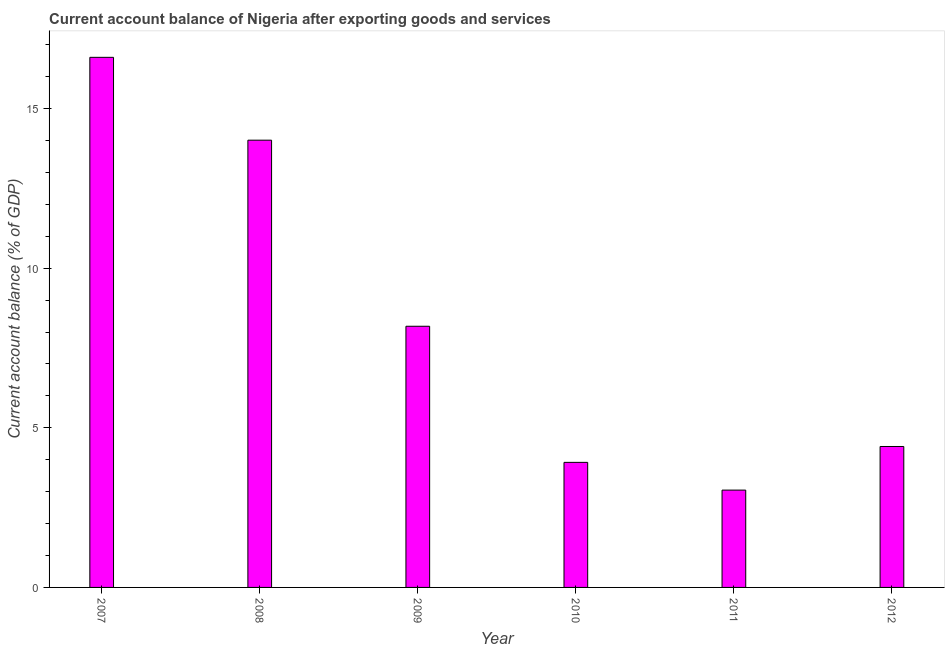What is the title of the graph?
Your response must be concise. Current account balance of Nigeria after exporting goods and services. What is the label or title of the X-axis?
Offer a very short reply. Year. What is the label or title of the Y-axis?
Ensure brevity in your answer.  Current account balance (% of GDP). What is the current account balance in 2010?
Offer a very short reply. 3.92. Across all years, what is the maximum current account balance?
Your answer should be compact. 16.61. Across all years, what is the minimum current account balance?
Give a very brief answer. 3.05. What is the sum of the current account balance?
Your answer should be compact. 50.18. What is the difference between the current account balance in 2009 and 2010?
Give a very brief answer. 4.26. What is the average current account balance per year?
Your answer should be compact. 8.36. What is the median current account balance?
Your answer should be very brief. 6.3. Do a majority of the years between 2009 and 2010 (inclusive) have current account balance greater than 2 %?
Your answer should be very brief. Yes. What is the ratio of the current account balance in 2011 to that in 2012?
Offer a very short reply. 0.69. Is the difference between the current account balance in 2008 and 2009 greater than the difference between any two years?
Offer a terse response. No. What is the difference between the highest and the second highest current account balance?
Offer a very short reply. 2.6. What is the difference between the highest and the lowest current account balance?
Offer a very short reply. 13.56. Are all the bars in the graph horizontal?
Offer a very short reply. No. Are the values on the major ticks of Y-axis written in scientific E-notation?
Your answer should be compact. No. What is the Current account balance (% of GDP) in 2007?
Provide a succinct answer. 16.61. What is the Current account balance (% of GDP) of 2008?
Give a very brief answer. 14.01. What is the Current account balance (% of GDP) in 2009?
Offer a terse response. 8.18. What is the Current account balance (% of GDP) of 2010?
Your answer should be compact. 3.92. What is the Current account balance (% of GDP) of 2011?
Ensure brevity in your answer.  3.05. What is the Current account balance (% of GDP) of 2012?
Offer a terse response. 4.42. What is the difference between the Current account balance (% of GDP) in 2007 and 2008?
Keep it short and to the point. 2.6. What is the difference between the Current account balance (% of GDP) in 2007 and 2009?
Offer a terse response. 8.43. What is the difference between the Current account balance (% of GDP) in 2007 and 2010?
Ensure brevity in your answer.  12.69. What is the difference between the Current account balance (% of GDP) in 2007 and 2011?
Provide a short and direct response. 13.56. What is the difference between the Current account balance (% of GDP) in 2007 and 2012?
Your answer should be compact. 12.19. What is the difference between the Current account balance (% of GDP) in 2008 and 2009?
Your answer should be compact. 5.83. What is the difference between the Current account balance (% of GDP) in 2008 and 2010?
Offer a very short reply. 10.09. What is the difference between the Current account balance (% of GDP) in 2008 and 2011?
Offer a very short reply. 10.96. What is the difference between the Current account balance (% of GDP) in 2008 and 2012?
Offer a very short reply. 9.6. What is the difference between the Current account balance (% of GDP) in 2009 and 2010?
Ensure brevity in your answer.  4.26. What is the difference between the Current account balance (% of GDP) in 2009 and 2011?
Give a very brief answer. 5.13. What is the difference between the Current account balance (% of GDP) in 2009 and 2012?
Your answer should be very brief. 3.77. What is the difference between the Current account balance (% of GDP) in 2010 and 2011?
Ensure brevity in your answer.  0.87. What is the difference between the Current account balance (% of GDP) in 2010 and 2012?
Ensure brevity in your answer.  -0.5. What is the difference between the Current account balance (% of GDP) in 2011 and 2012?
Your answer should be very brief. -1.37. What is the ratio of the Current account balance (% of GDP) in 2007 to that in 2008?
Offer a terse response. 1.19. What is the ratio of the Current account balance (% of GDP) in 2007 to that in 2009?
Your answer should be compact. 2.03. What is the ratio of the Current account balance (% of GDP) in 2007 to that in 2010?
Provide a succinct answer. 4.24. What is the ratio of the Current account balance (% of GDP) in 2007 to that in 2011?
Your answer should be very brief. 5.45. What is the ratio of the Current account balance (% of GDP) in 2007 to that in 2012?
Ensure brevity in your answer.  3.76. What is the ratio of the Current account balance (% of GDP) in 2008 to that in 2009?
Your response must be concise. 1.71. What is the ratio of the Current account balance (% of GDP) in 2008 to that in 2010?
Provide a succinct answer. 3.58. What is the ratio of the Current account balance (% of GDP) in 2008 to that in 2011?
Offer a very short reply. 4.6. What is the ratio of the Current account balance (% of GDP) in 2008 to that in 2012?
Your response must be concise. 3.17. What is the ratio of the Current account balance (% of GDP) in 2009 to that in 2010?
Offer a terse response. 2.09. What is the ratio of the Current account balance (% of GDP) in 2009 to that in 2011?
Make the answer very short. 2.68. What is the ratio of the Current account balance (% of GDP) in 2009 to that in 2012?
Offer a very short reply. 1.85. What is the ratio of the Current account balance (% of GDP) in 2010 to that in 2011?
Give a very brief answer. 1.28. What is the ratio of the Current account balance (% of GDP) in 2010 to that in 2012?
Provide a succinct answer. 0.89. What is the ratio of the Current account balance (% of GDP) in 2011 to that in 2012?
Your response must be concise. 0.69. 